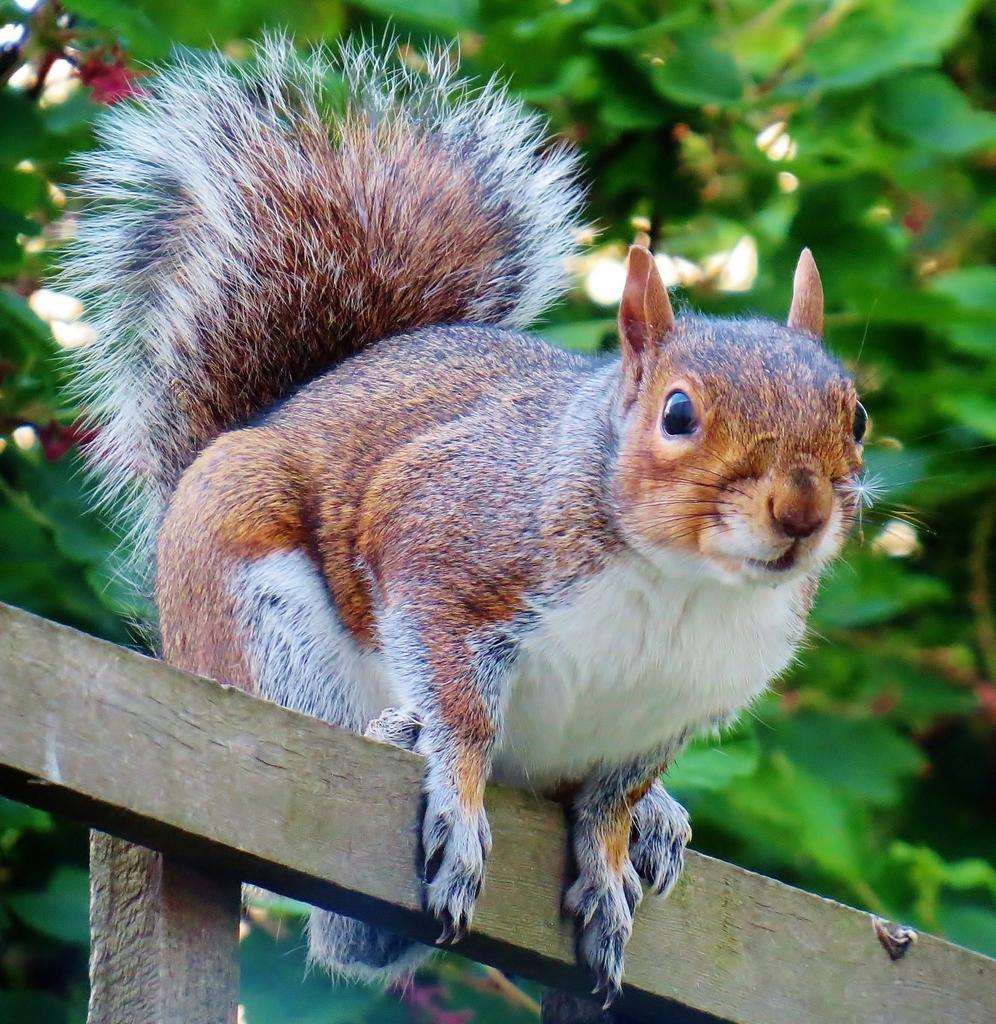Could you give a brief overview of what you see in this image? This is the squirrel standing on the wooden stick. In the background, I think these are the trees with leaves. 